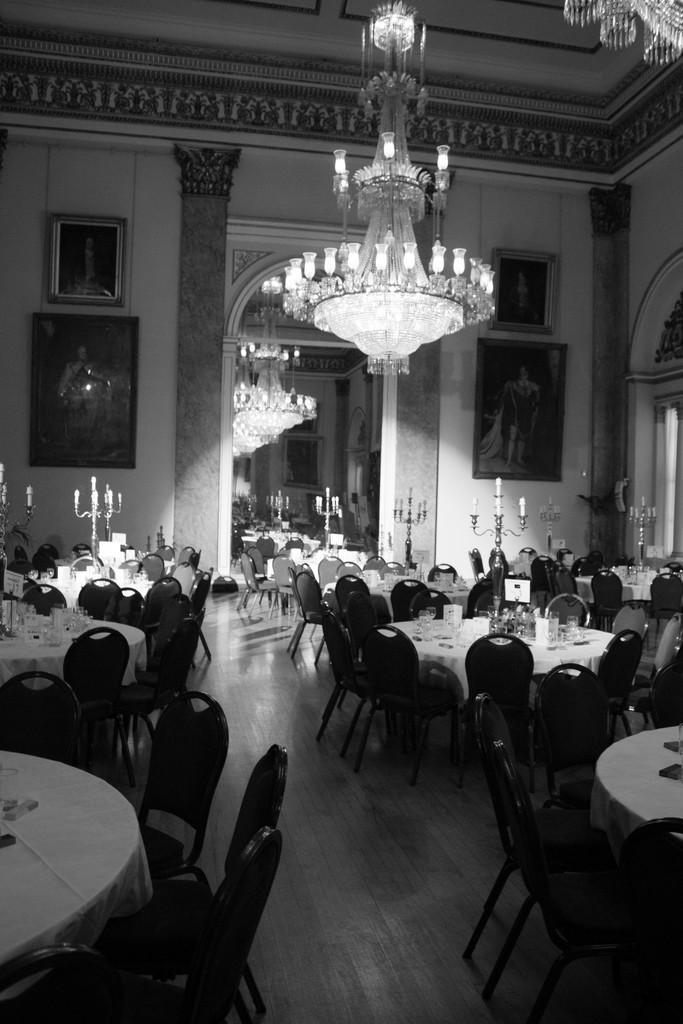How would you summarize this image in a sentence or two? This is a black and white image and here we can see glasses and some other objects on the tables and there are chairs, stands, frames on the wall, a mirror and at the top, there is light and roof. At the bottom, there is floor. 